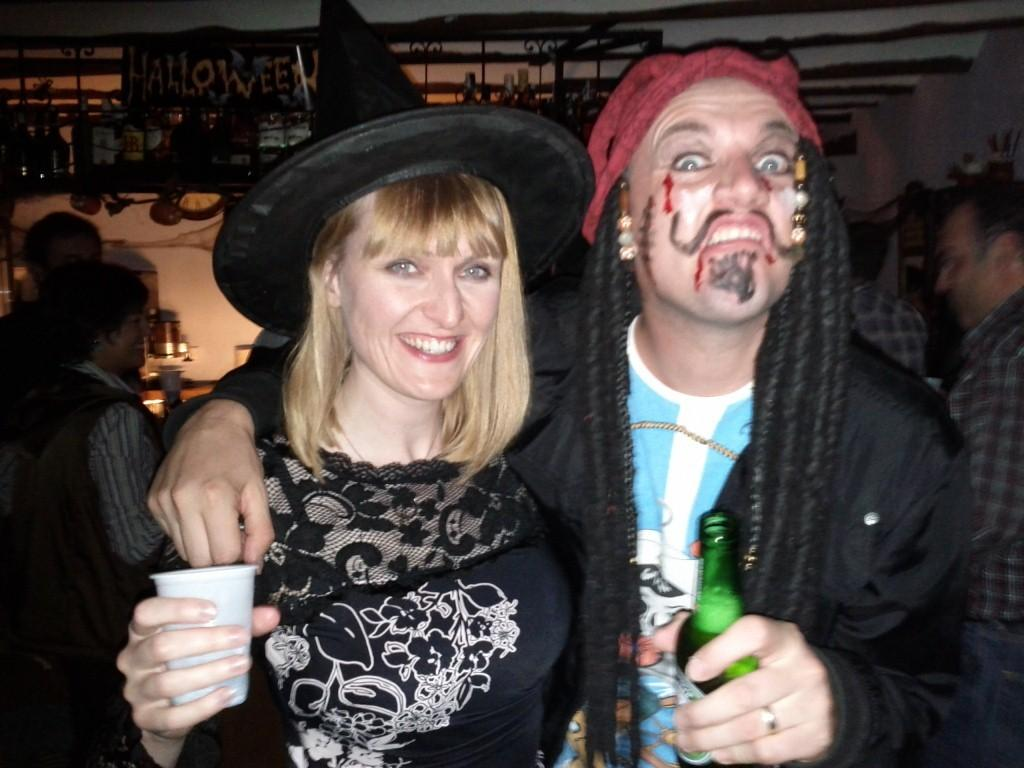How many people are in the image? There are two people in the image. Can you describe the expressions of the people in the image? The woman is smiling. What is the woman holding in the image? The woman is holding a glass. Can you describe the other person in the image? The other person is a man. What is the man holding in the image? The man is holding a bottle. What can be seen in the background of the image? There are people, bottles on a surface, a wall, and a board in the background. Are the two people in the image having an argument? There is no indication of an argument in the image; the woman is smiling. Can you tell me how many friends are present in the image? The term "friend" is not mentioned in the image, so it cannot be determined from the image. 